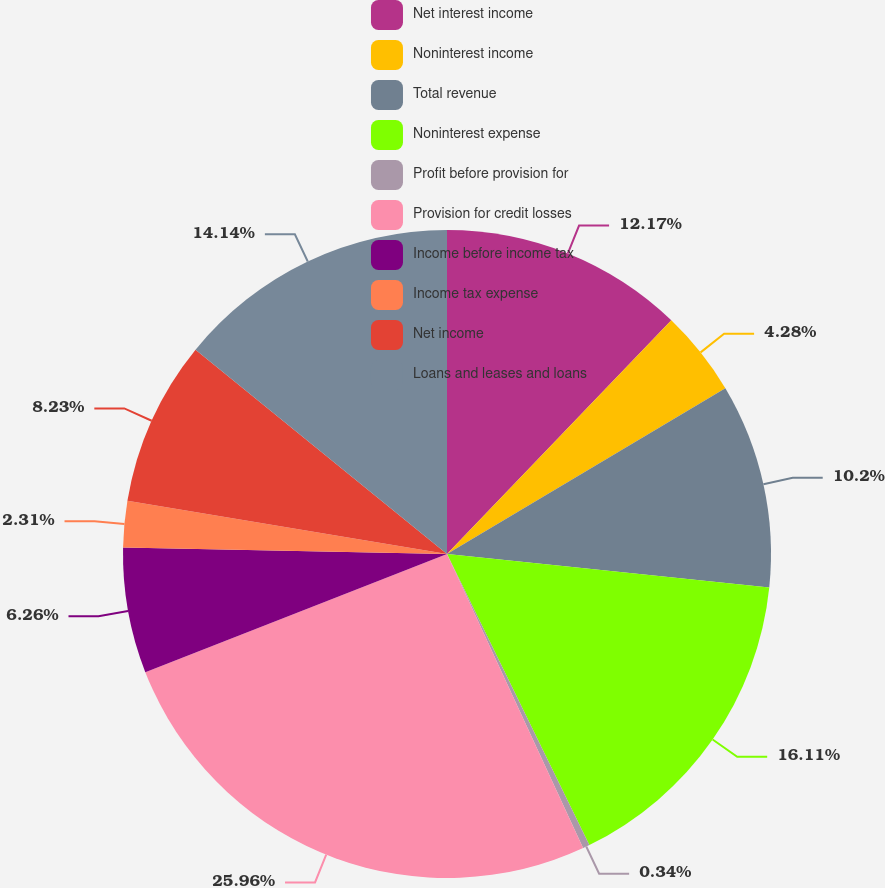Convert chart to OTSL. <chart><loc_0><loc_0><loc_500><loc_500><pie_chart><fcel>Net interest income<fcel>Noninterest income<fcel>Total revenue<fcel>Noninterest expense<fcel>Profit before provision for<fcel>Provision for credit losses<fcel>Income before income tax<fcel>Income tax expense<fcel>Net income<fcel>Loans and leases and loans<nl><fcel>12.17%<fcel>4.28%<fcel>10.2%<fcel>16.11%<fcel>0.34%<fcel>25.96%<fcel>6.26%<fcel>2.31%<fcel>8.23%<fcel>14.14%<nl></chart> 